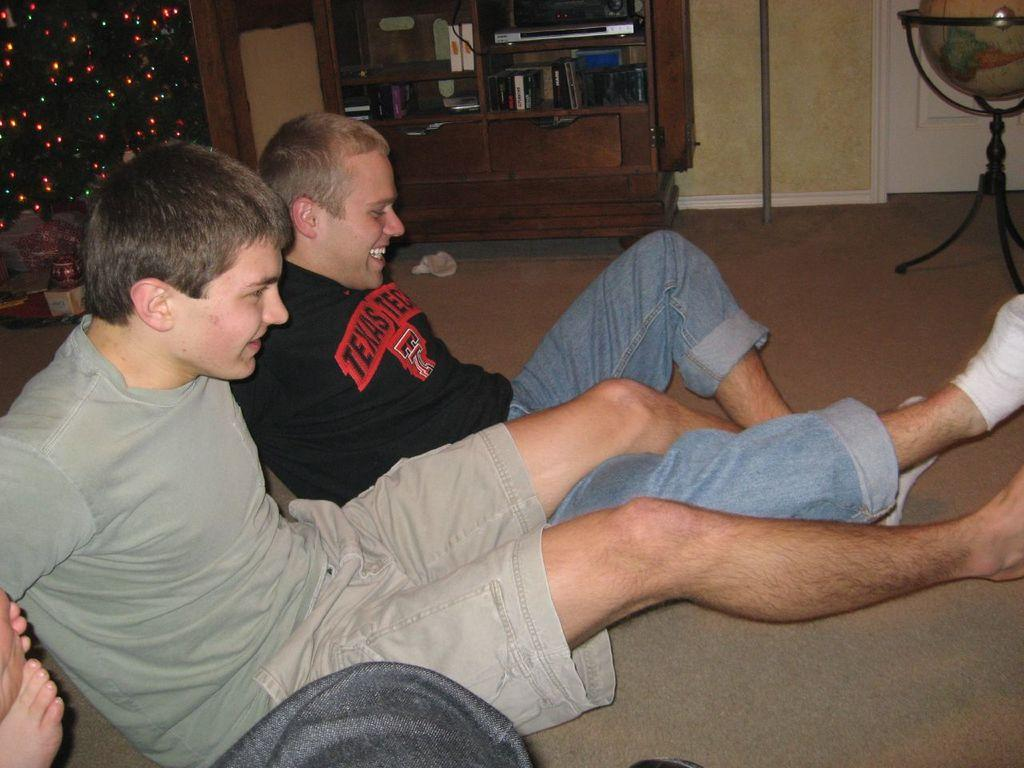<image>
Share a concise interpretation of the image provided. A man in a grey top and a man ina black top with a Texas Tech logo on it leg wrestle on the floor near a christmas tree. 